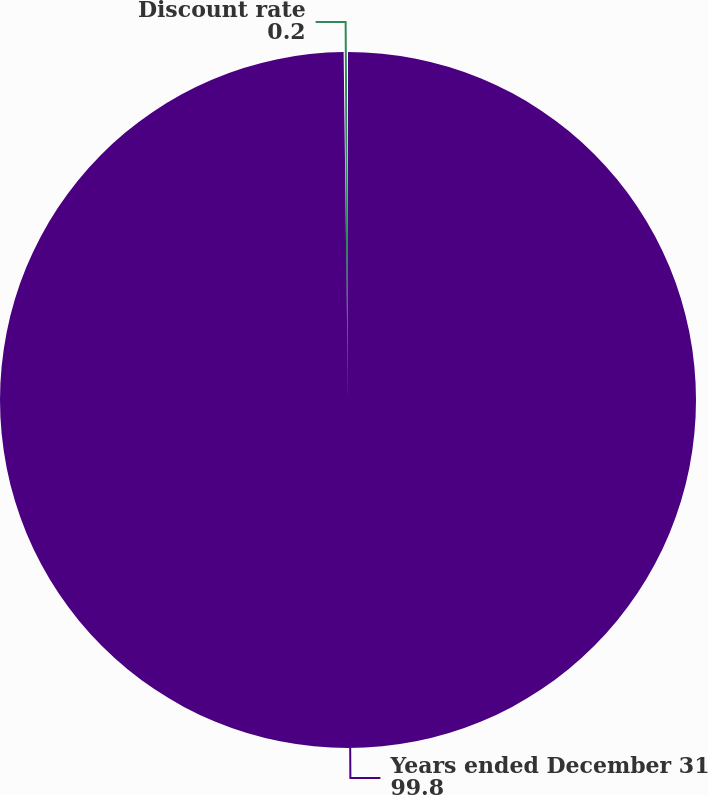Convert chart to OTSL. <chart><loc_0><loc_0><loc_500><loc_500><pie_chart><fcel>Years ended December 31<fcel>Discount rate<nl><fcel>99.8%<fcel>0.2%<nl></chart> 